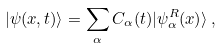Convert formula to latex. <formula><loc_0><loc_0><loc_500><loc_500>| \psi ( x , t ) \rangle = \sum _ { \alpha } C _ { \alpha } ( t ) | \psi ^ { R } _ { \alpha } ( x ) \rangle \, ,</formula> 